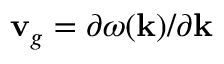<formula> <loc_0><loc_0><loc_500><loc_500>{ v } _ { g } = \partial \omega ( { k } ) / \partial { k }</formula> 